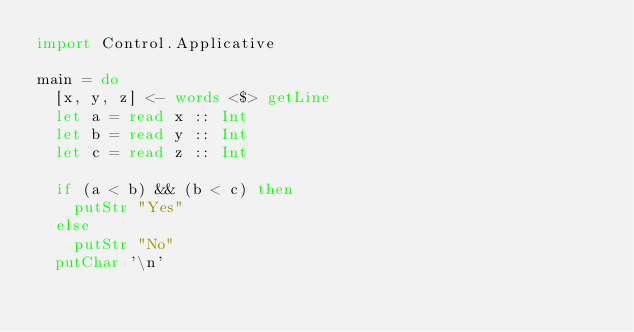Convert code to text. <code><loc_0><loc_0><loc_500><loc_500><_Haskell_>import Control.Applicative

main = do
  [x, y, z] <- words <$> getLine
  let a = read x :: Int
  let b = read y :: Int
  let c = read z :: Int

  if (a < b) && (b < c) then
    putStr "Yes"
  else
    putStr "No"
  putChar '\n'</code> 